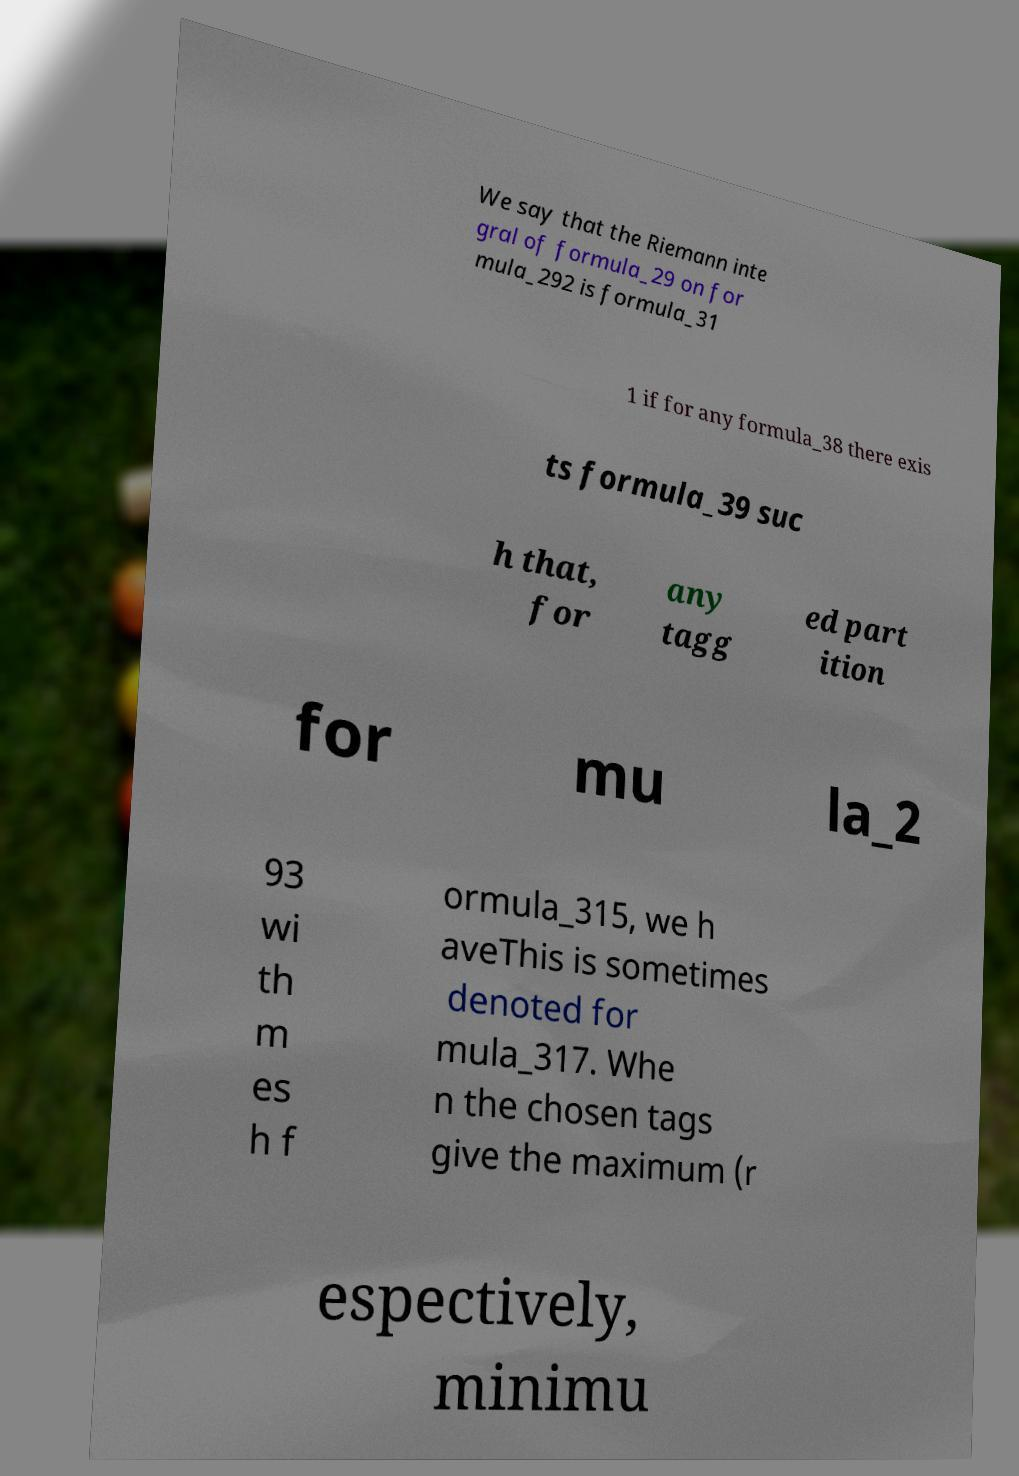I need the written content from this picture converted into text. Can you do that? We say that the Riemann inte gral of formula_29 on for mula_292 is formula_31 1 if for any formula_38 there exis ts formula_39 suc h that, for any tagg ed part ition for mu la_2 93 wi th m es h f ormula_315, we h aveThis is sometimes denoted for mula_317. Whe n the chosen tags give the maximum (r espectively, minimu 